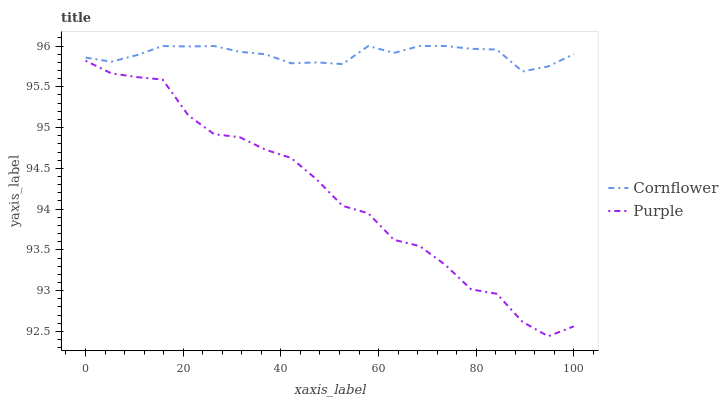Does Purple have the minimum area under the curve?
Answer yes or no. Yes. Does Cornflower have the maximum area under the curve?
Answer yes or no. Yes. Does Cornflower have the minimum area under the curve?
Answer yes or no. No. Is Cornflower the smoothest?
Answer yes or no. Yes. Is Purple the roughest?
Answer yes or no. Yes. Is Cornflower the roughest?
Answer yes or no. No. Does Purple have the lowest value?
Answer yes or no. Yes. Does Cornflower have the lowest value?
Answer yes or no. No. Does Cornflower have the highest value?
Answer yes or no. Yes. Is Purple less than Cornflower?
Answer yes or no. Yes. Is Cornflower greater than Purple?
Answer yes or no. Yes. Does Purple intersect Cornflower?
Answer yes or no. No. 